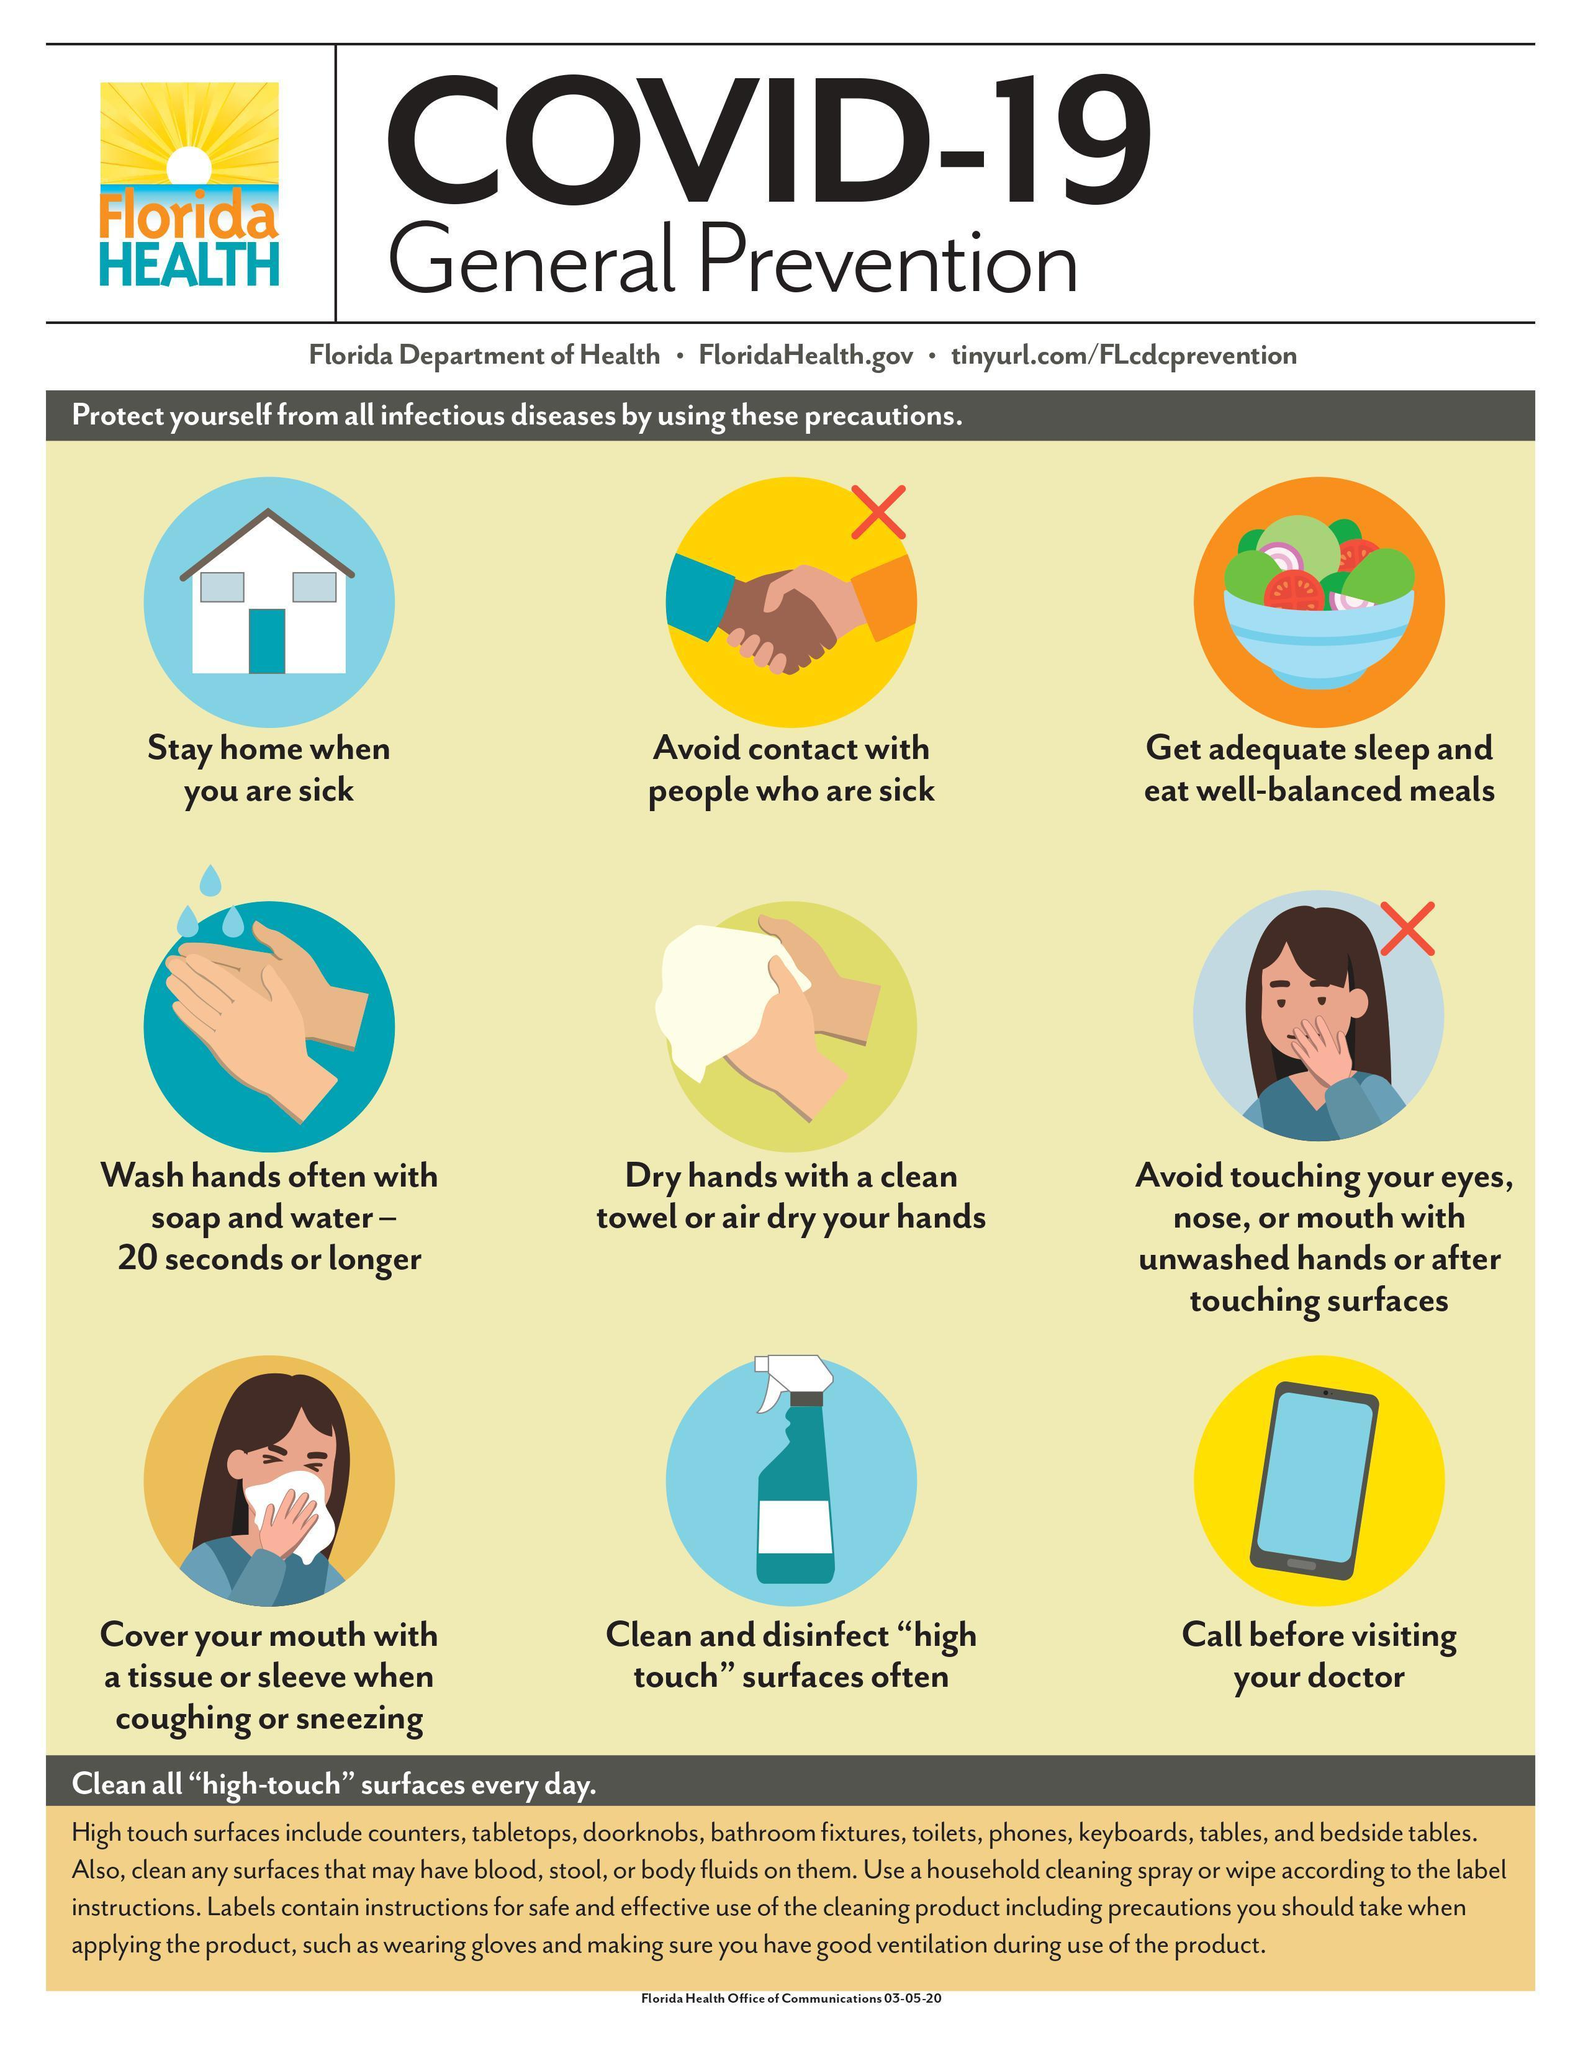Which precaution is represented by the image of a bowl of fruits and vegetables?
Answer the question with a short phrase. Get adequate sleep and eat well-balanced meals From among the precautions, how many mention the things you 'should not do'? 2 What is the last precaution mentioned? Call before visiting your doctor When is it necessary to stay at home? When you are sick Who should be avoided? People who are sick What should you cover your mouth with, while coughing or sneezing? a tissue or sleeve What should you wash your hands with? Soap and water How many of these precautions mention the things that you 'should do'? 7 What is the minimum duration for safely washing your hands? 20 seconds What parts of the face shouldn't you touch with  unwashed hands? Eyes, nose, mouth How many precautions are mentioned? 9 